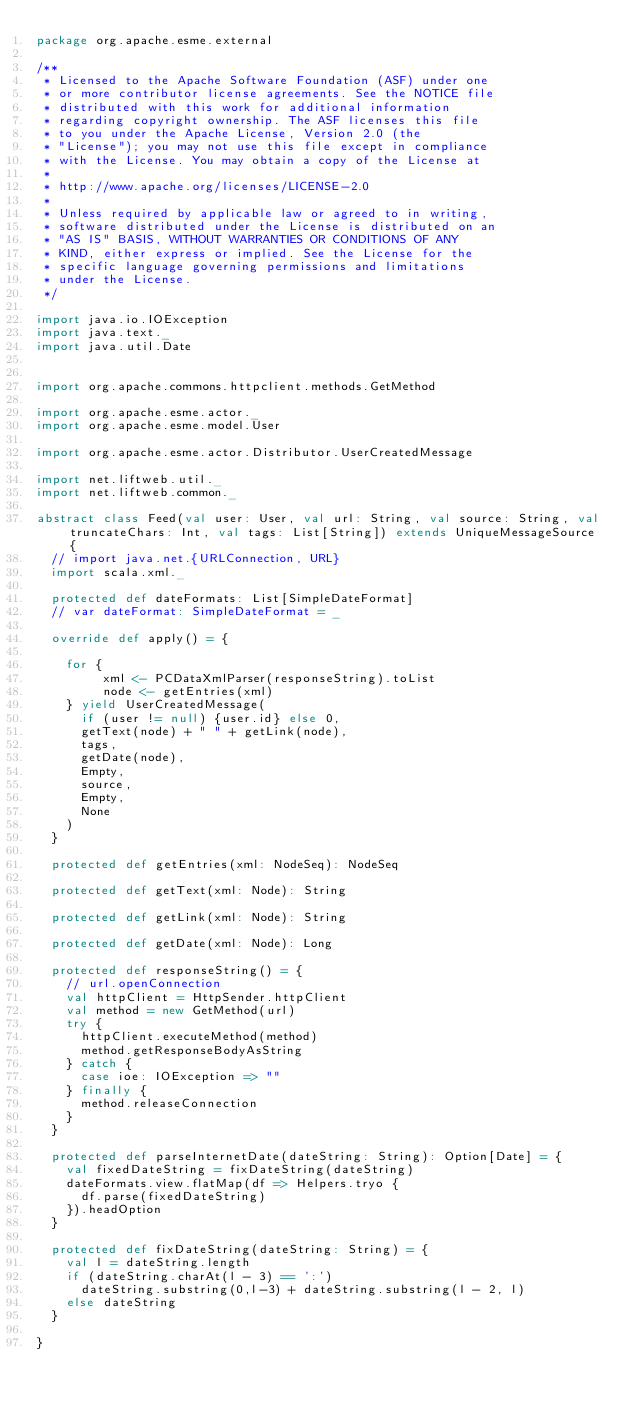Convert code to text. <code><loc_0><loc_0><loc_500><loc_500><_Scala_>package org.apache.esme.external

/**
 * Licensed to the Apache Software Foundation (ASF) under one
 * or more contributor license agreements. See the NOTICE file
 * distributed with this work for additional information
 * regarding copyright ownership. The ASF licenses this file
 * to you under the Apache License, Version 2.0 (the
 * "License"); you may not use this file except in compliance
 * with the License. You may obtain a copy of the License at
 *
 * http://www.apache.org/licenses/LICENSE-2.0
 *
 * Unless required by applicable law or agreed to in writing,
 * software distributed under the License is distributed on an
 * "AS IS" BASIS, WITHOUT WARRANTIES OR CONDITIONS OF ANY
 * KIND, either express or implied. See the License for the
 * specific language governing permissions and limitations
 * under the License.
 */

import java.io.IOException
import java.text._
import java.util.Date


import org.apache.commons.httpclient.methods.GetMethod

import org.apache.esme.actor._
import org.apache.esme.model.User

import org.apache.esme.actor.Distributor.UserCreatedMessage

import net.liftweb.util._
import net.liftweb.common._

abstract class Feed(val user: User, val url: String, val source: String, val truncateChars: Int, val tags: List[String]) extends UniqueMessageSource {
  // import java.net.{URLConnection, URL}
  import scala.xml._

  protected def dateFormats: List[SimpleDateFormat]
  // var dateFormat: SimpleDateFormat = _

  override def apply() = {
    
    for {
         xml <- PCDataXmlParser(responseString).toList
         node <- getEntries(xml)
    } yield UserCreatedMessage(
      if (user != null) {user.id} else 0,
      getText(node) + " " + getLink(node),
      tags,
      getDate(node),
      Empty,
      source,
      Empty,
      None
    )
  }
  
  protected def getEntries(xml: NodeSeq): NodeSeq
  
  protected def getText(xml: Node): String
  
  protected def getLink(xml: Node): String
  
  protected def getDate(xml: Node): Long
  
  protected def responseString() = {
    // url.openConnection
    val httpClient = HttpSender.httpClient
    val method = new GetMethod(url)
    try {
      httpClient.executeMethod(method)
      method.getResponseBodyAsString
    } catch {
      case ioe: IOException => ""
    } finally {
      method.releaseConnection
    }
  }
  
  protected def parseInternetDate(dateString: String): Option[Date] = {
    val fixedDateString = fixDateString(dateString)
    dateFormats.view.flatMap(df => Helpers.tryo {
      df.parse(fixedDateString)
    }).headOption
  }
  
  protected def fixDateString(dateString: String) = {
    val l = dateString.length
    if (dateString.charAt(l - 3) == ':')
      dateString.substring(0,l-3) + dateString.substring(l - 2, l)
    else dateString
  }

}

</code> 